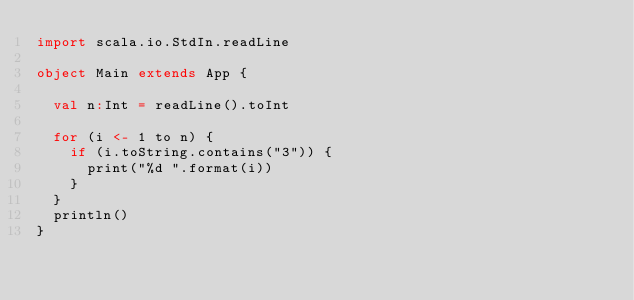Convert code to text. <code><loc_0><loc_0><loc_500><loc_500><_Scala_>import scala.io.StdIn.readLine

object Main extends App {

  val n:Int = readLine().toInt

  for (i <- 1 to n) {
    if (i.toString.contains("3")) {
      print("%d ".format(i))
    }
  }
  println()
}</code> 